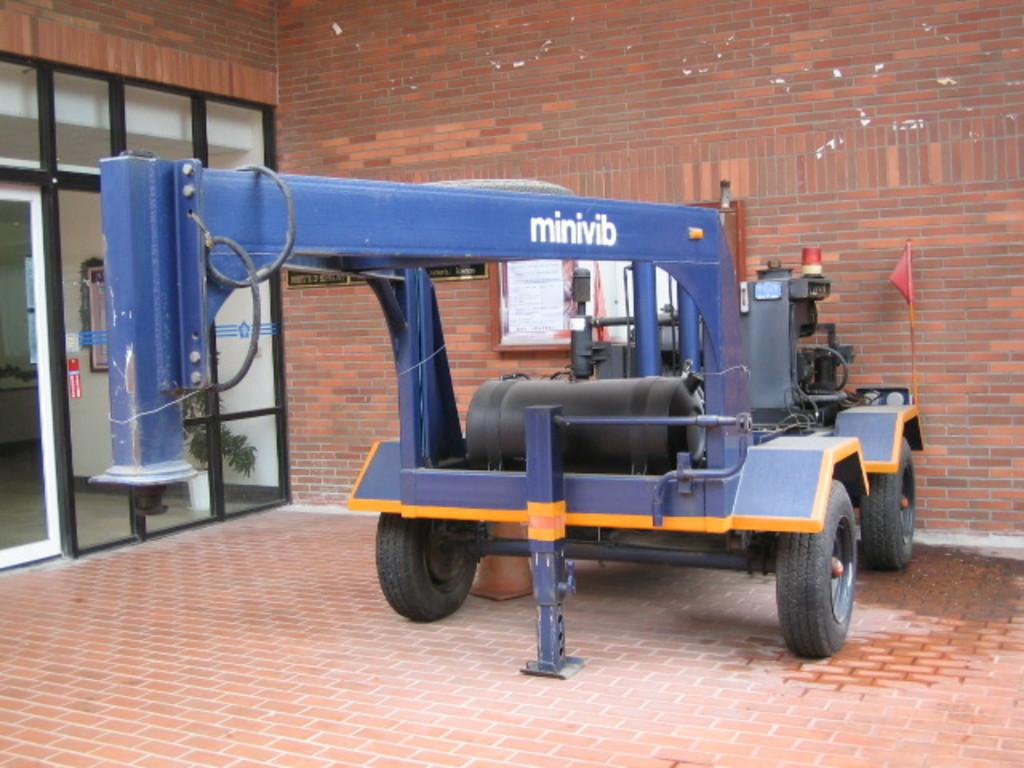What can be seen parked in the image? There is a vehicle parked in the image. Where is the vehicle parked in relation to the door? The vehicle is parked outside a door. What is the wall behind the vehicle made of? The wall behind the vehicle is a brick wall. What type of door is visible on the left side of the image? The door is made of glass. How many turkeys are visible in the image? There are no turkeys present in the image. Is the family gathered around the vehicle in the image? There is no mention of a family in the image, and no family members are visible. 